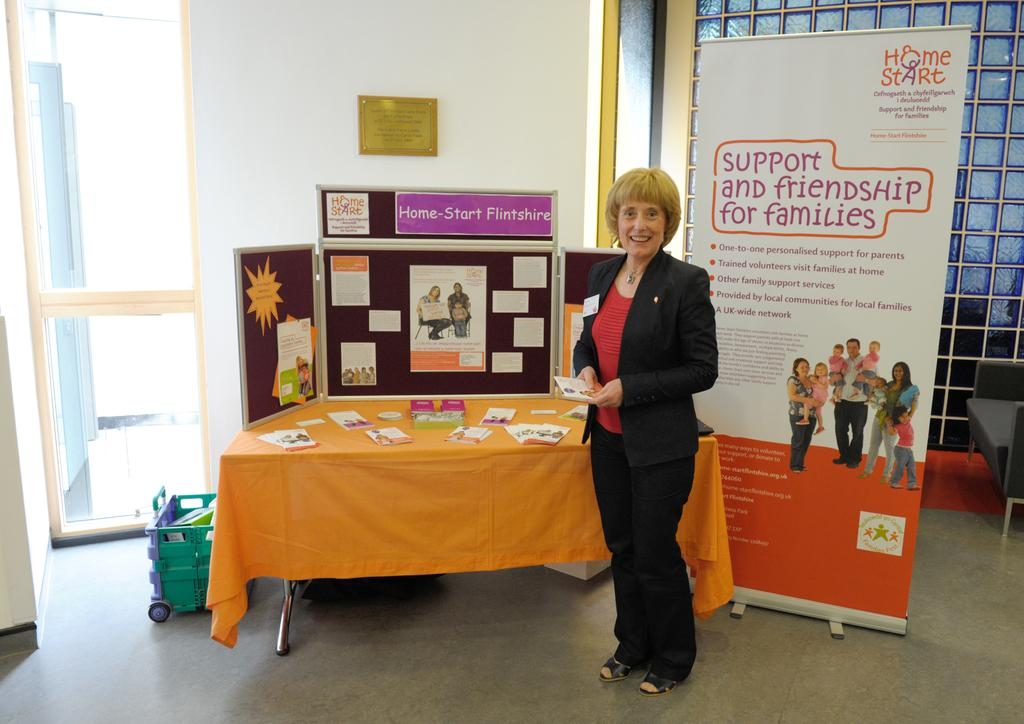What is the person in the image holding? The person is holding a paper. What can be seen hanging in the image? There is a banner visible in the image. What type of structure is present in the image? There is a wall in the image. What is on the wall in the image? There is a board in the image. What type of decorations are present in the image? There are posters in the image. What is on the table in the image? There are papers on a table in the image. What is on the floor in the image? There is a basket on the floor in the image. How many deer can be seen in the image? There are no deer present in the image. What type of zoo can be seen in the image? There is no zoo present in the image. 